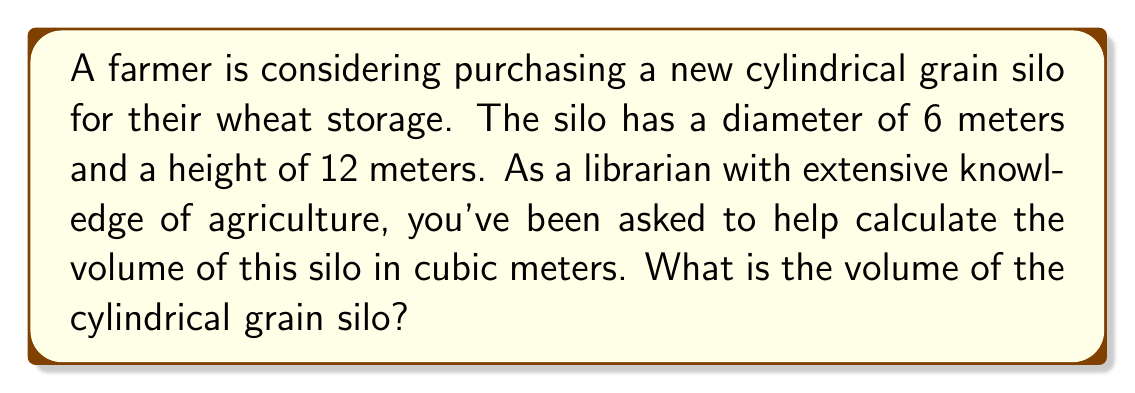Help me with this question. To calculate the volume of a cylindrical grain silo, we need to use the formula for the volume of a cylinder:

$$V = \pi r^2 h$$

Where:
$V$ = volume
$r$ = radius of the base
$h$ = height of the cylinder

Given:
- Diameter = 6 meters
- Height = 12 meters

Step 1: Calculate the radius
The radius is half the diameter:
$r = \frac{6}{2} = 3$ meters

Step 2: Apply the volume formula
$$\begin{align}
V &= \pi r^2 h \\
&= \pi (3\text{ m})^2 (12\text{ m}) \\
&= \pi (9\text{ m}^2) (12\text{ m}) \\
&= 108\pi\text{ m}^3
\end{align}$$

Step 3: Calculate the final value
$V = 108\pi \approx 339.29\text{ m}^3$

[asy]
import geometry;

size(200);
real r = 3;
real h = 12;
path base = circle((0,0), r);
path top = circle((0,h), r);
draw(base);
draw(top);
draw((r,0)--(r,h));
draw((-r,0)--(-r,h));
draw((0,0)--(r,0), arrow=Arrow(TeXHead));
draw((r,0)--(r,h/2), arrow=Arrow(TeXHead));
label("r", (r/2,0), S);
label("h", (r,h/2), E);
</asy>
Answer: The volume of the cylindrical grain silo is approximately 339.29 cubic meters. 